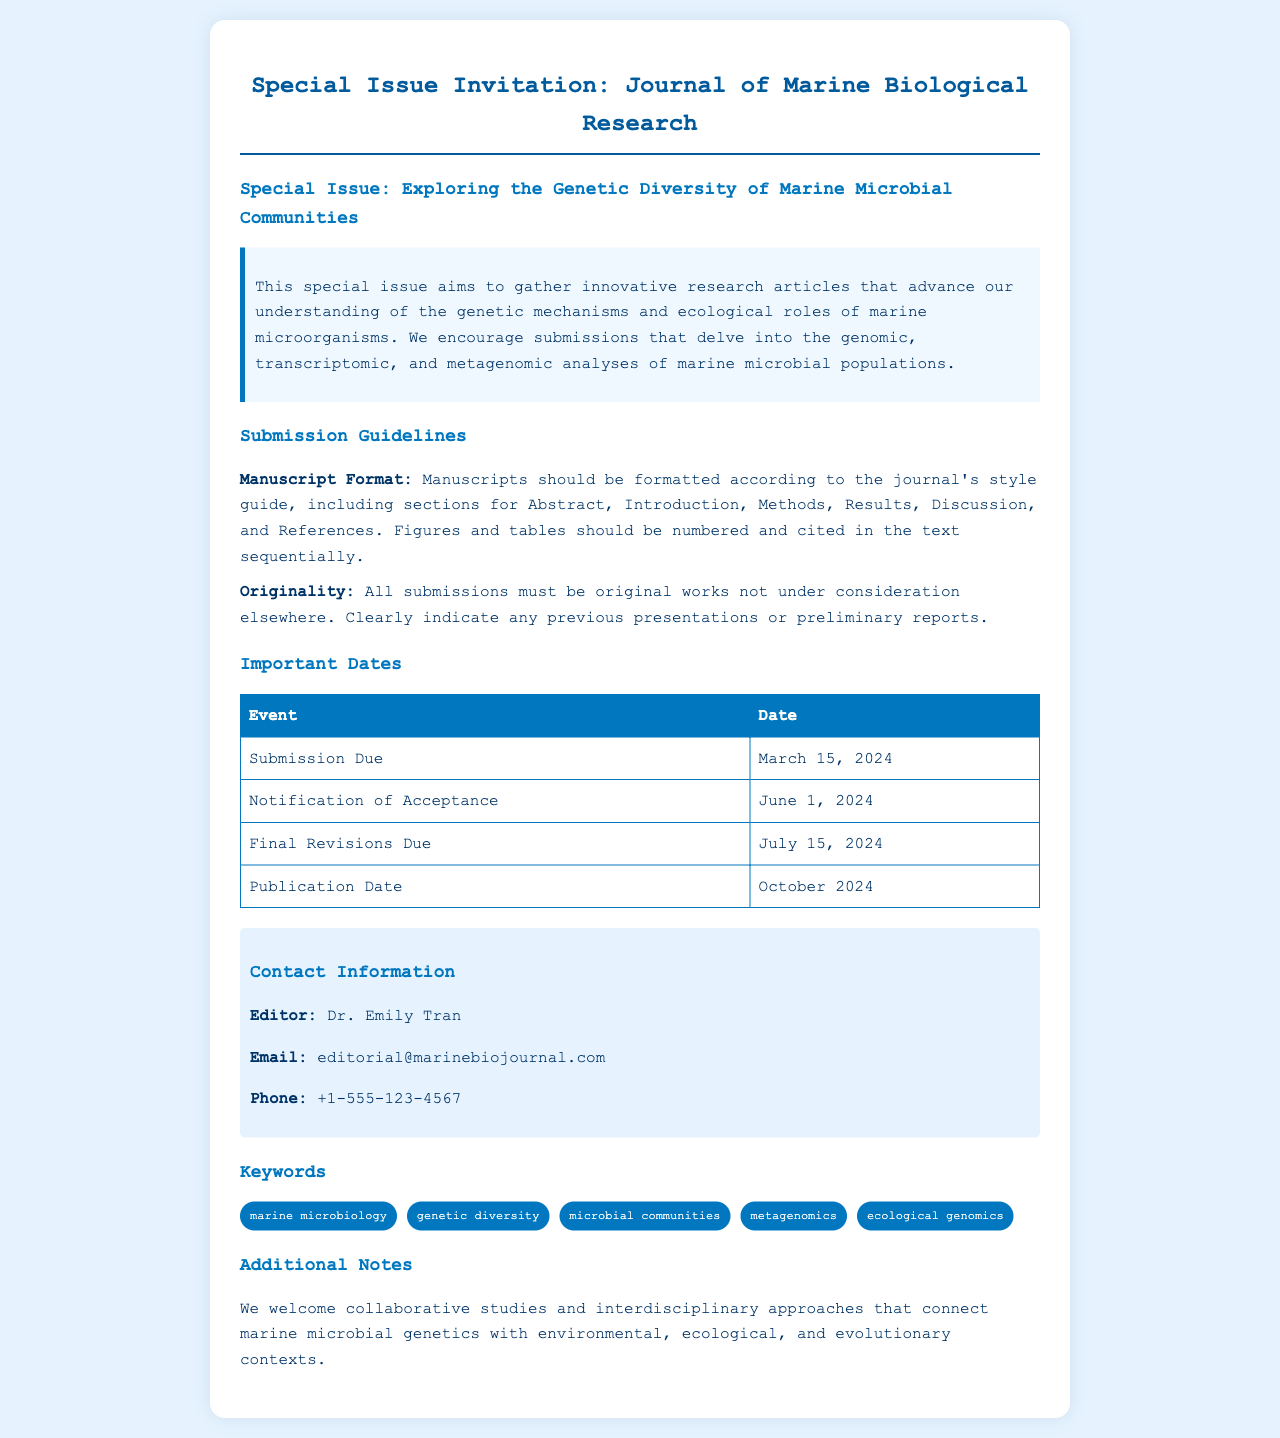what is the title of the special issue? The title of the special issue is listed in the heading.
Answer: Exploring the Genetic Diversity of Marine Microbial Communities who is the editor for this special issue? The editor's name is mentioned in the contact information section.
Answer: Dr. Emily Tran when is the submission due date? The submission due date is specified in the important dates section.
Answer: March 15, 2024 what must all submissions be? This requirement is stated in the submission guidelines.
Answer: original works not under consideration elsewhere what is the publication date of the special issue? The publication date is provided in the important dates section.
Answer: October 2024 how many key dates are listed in the document? The document lists several events with their respective dates.
Answer: four what type of studies are welcomed according to the additional notes? The note encourages a certain type of study approach.
Answer: collaborative studies and interdisciplinary approaches what is the email address for editorial contact? The email address for the editor is provided in the contact information.
Answer: editorial@marinebiojournal.com 